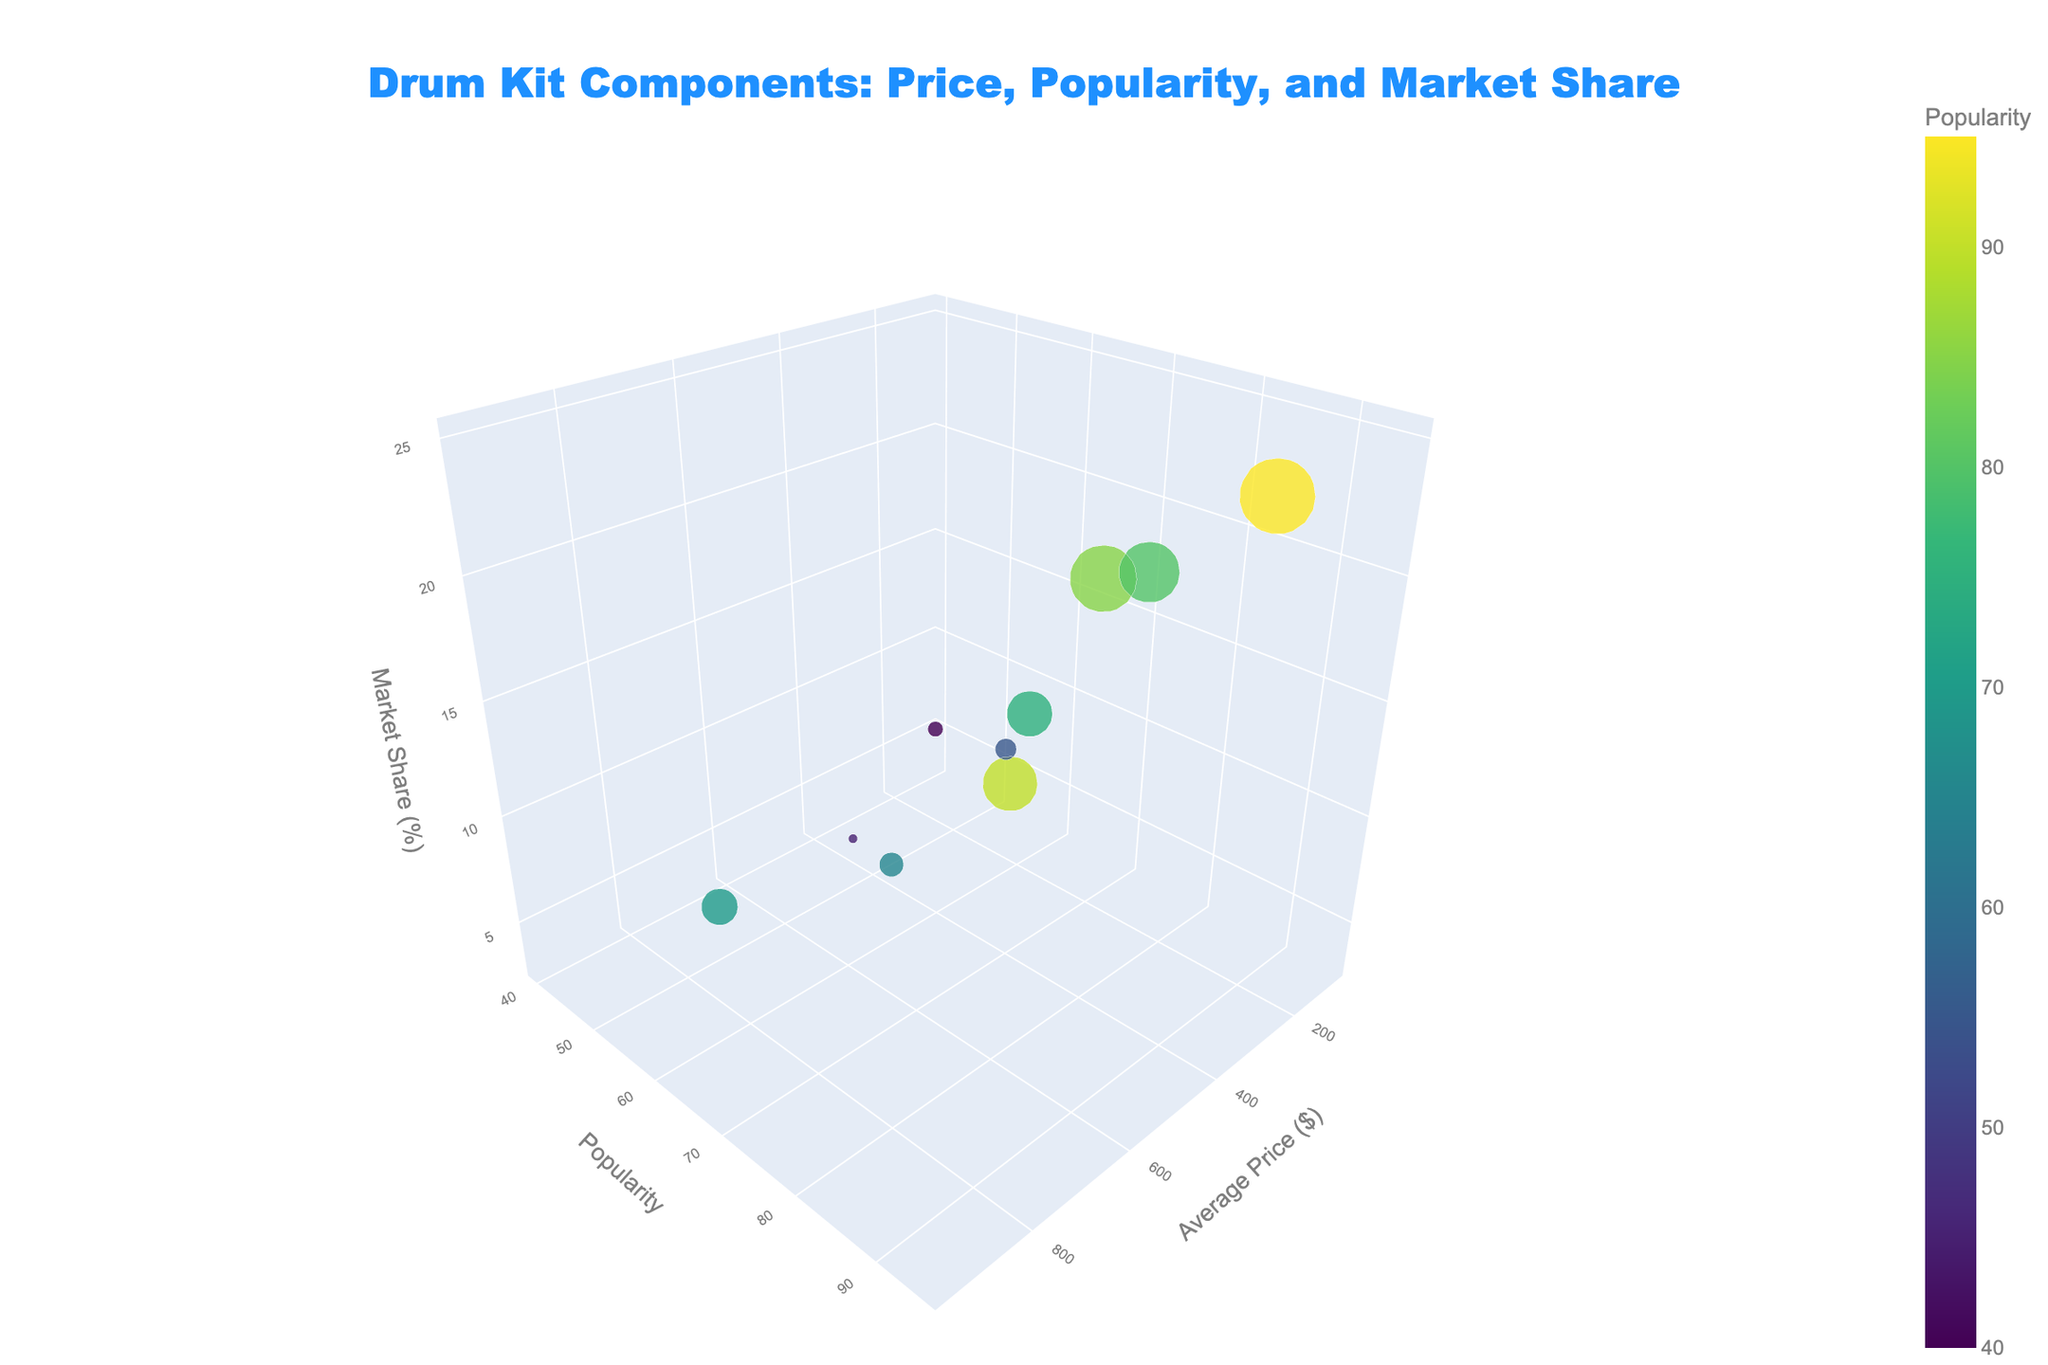What's the title of the chart? The title is displayed at the top of the chart. It provides a summary of what the chart represents. The prominent fonts and placement make it easy to notice.
Answer: Drum Kit Components: Price, Popularity, and Market Share How many components are plotted in the chart? By counting the bubbles, each representing a drum kit component, you can determine the total number. The figure includes various drum kit components such as Snare Drum, Bass Drum, etc.
Answer: 10 Which component has the highest popularity? Look at the vertical (y) axis which denotes popularity and identify the highest point. The label or tooltip for that bubble will provide the component's name.
Answer: Hi-Hat Cymbals What is the average price range of the Snare Drum? The x-axis represents the average price range. For the Snare Drum bubble, read the x-coordinate value displayed in the tooltip or by hovering over it.
Answer: 500 What's the relationship between popularity and market share of Cowbell? Check the y-axis for popularity and z-axis for market share. Locate the Cowbell's position and read off the coordinates.
Answer: Popularity: 40, Market Share: 5% Which manufacturer has the largest market share? Look at the size of the bubbles, with larger sizes representing a larger market share. Find the largest one and read the component's or manufacturer's name from the label or tooltip.
Answer: Zildjian Compare the market share of Ride Cymbal and Crash Cymbal. Locate the Ride Cymbal and Crash Cymbal on the z-axis. Compare their z-coordinates.
Answer: Ride Cymbal: 15%, Crash Cymbal: 20% What is the average market share of all cymbals? Identify the market share (z-values) of Hi-Hat Cymbals, Crash Cymbal, Ride Cymbal, Splash Cymbal, and China Cymbal. Calculate their arithmetic mean. (25 + 20 + 15 + 7 + 3) / 5 = 14%
Answer: 14% Which component has the lowest average price? Locate the bubble closest to the lowest x-axis value. Hover over to read the component's name.
Answer: Cowbell How does the popularity of Splash Cymbal compare to China Cymbal? Compare the y-coordinates of Splash Cymbal and China Cymbal. Identify which is higher or lower.
Answer: Splash Cymbal is more popular than China Cymbal 